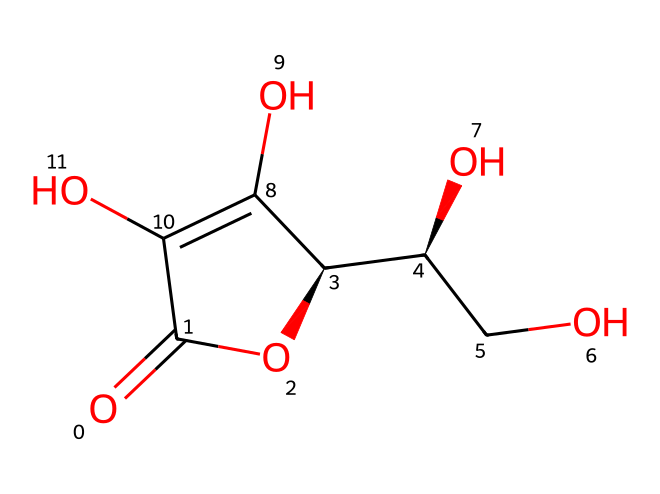What is the molecular formula of this antioxidant? The SMILES representation can be converted to the molecular formula by counting each atom. Here, you can see there are 6 carbons, 8 hydrogens, 6 oxygens, leading to the formula C6H8O6.
Answer: C6H8O6 How many hydroxyl (–OH) groups are present in the structure? By examining the structure, we can identify the –OH groups, which are evident at various positions in the molecular structure. There are four –OH groups in total.
Answer: 4 What functional groups are present in this antioxidant? The structure reveals the presence of hydroxyl (–OH) groups and carbonyl (C=O) functional groups. The hydroxyl groups contribute to antioxidant properties.
Answer: hydroxyl, carbonyl What is the stereochemistry indicated in the structure? The SMILES show chiral centers denoted by the "@" symbol, indicating specific stereochemistry. There are two chiral carbon atoms, leading to distinct stereoisomers.
Answer: 2 chiral centers What is the primary role of vitamin C as an antioxidant? Vitamin C is known primarily for its ability to donate electrons, thus neutralizing free radicals generated in oxidative stress, which is crucial for skin health.
Answer: electron donor Which type of compounds does this structure belong to? This chemical structure is recognized as an antioxidant due to its efficacy in scavenging free radicals and mitigating oxidative damage within skin care formulations.
Answer: antioxidant 